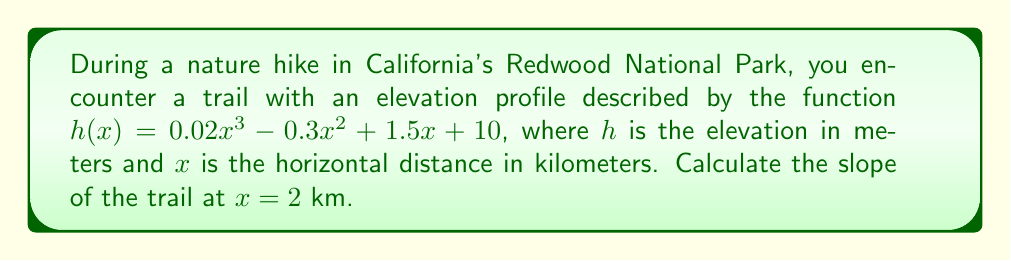Could you help me with this problem? To find the slope of the trail at a specific point, we need to calculate the derivative of the elevation function $h(x)$ and evaluate it at the given point.

Step 1: Find the derivative of $h(x)$
$$h(x) = 0.02x^3 - 0.3x^2 + 1.5x + 10$$
$$h'(x) = 0.06x^2 - 0.6x + 1.5$$

Step 2: Evaluate the derivative at $x = 2$
$$h'(2) = 0.06(2)^2 - 0.6(2) + 1.5$$
$$h'(2) = 0.06(4) - 1.2 + 1.5$$
$$h'(2) = 0.24 - 1.2 + 1.5$$
$$h'(2) = 0.54$$

Step 3: Interpret the result
The slope of 0.54 means that for every 1 kilometer of horizontal distance at this point, the trail rises 0.54 meters vertically. This can also be expressed as a percentage: 0.54 * 100 = 54%.
Answer: $0.54$ or $54\%$ 